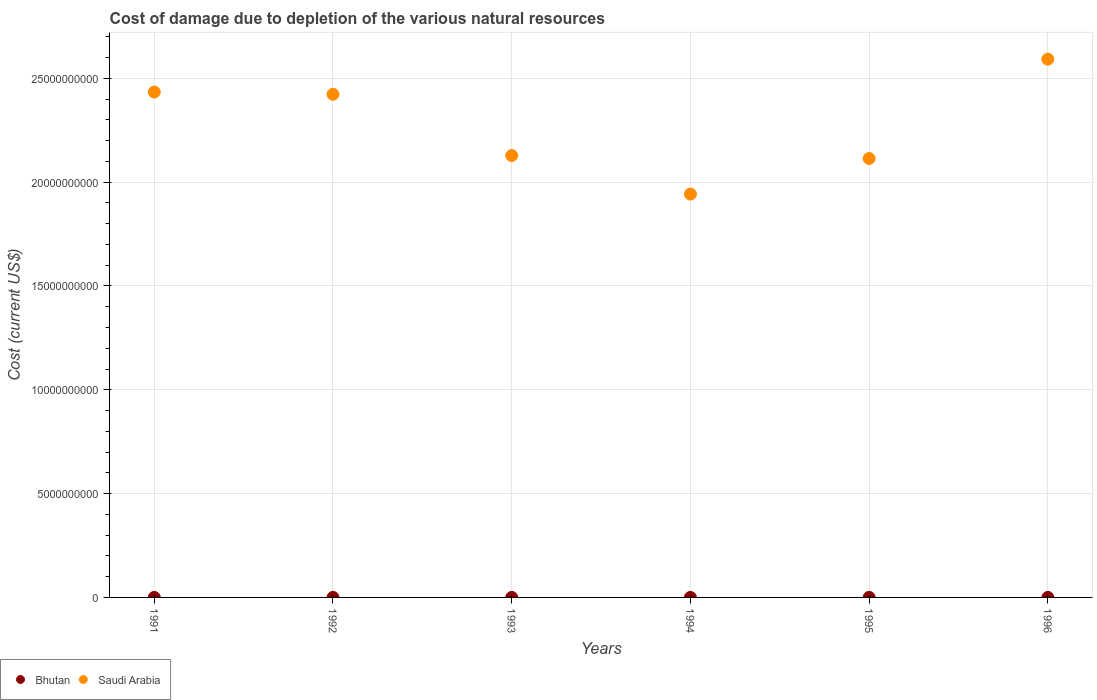How many different coloured dotlines are there?
Offer a very short reply. 2. Is the number of dotlines equal to the number of legend labels?
Keep it short and to the point. Yes. What is the cost of damage caused due to the depletion of various natural resources in Saudi Arabia in 1991?
Keep it short and to the point. 2.43e+1. Across all years, what is the maximum cost of damage caused due to the depletion of various natural resources in Bhutan?
Your response must be concise. 3.59e+05. Across all years, what is the minimum cost of damage caused due to the depletion of various natural resources in Bhutan?
Your response must be concise. 1.20e+04. What is the total cost of damage caused due to the depletion of various natural resources in Saudi Arabia in the graph?
Offer a very short reply. 1.36e+11. What is the difference between the cost of damage caused due to the depletion of various natural resources in Saudi Arabia in 1994 and that in 1995?
Provide a succinct answer. -1.71e+09. What is the difference between the cost of damage caused due to the depletion of various natural resources in Bhutan in 1993 and the cost of damage caused due to the depletion of various natural resources in Saudi Arabia in 1995?
Provide a succinct answer. -2.11e+1. What is the average cost of damage caused due to the depletion of various natural resources in Saudi Arabia per year?
Give a very brief answer. 2.27e+1. In the year 1993, what is the difference between the cost of damage caused due to the depletion of various natural resources in Bhutan and cost of damage caused due to the depletion of various natural resources in Saudi Arabia?
Keep it short and to the point. -2.13e+1. What is the ratio of the cost of damage caused due to the depletion of various natural resources in Saudi Arabia in 1991 to that in 1992?
Your answer should be compact. 1. Is the cost of damage caused due to the depletion of various natural resources in Saudi Arabia in 1992 less than that in 1995?
Give a very brief answer. No. Is the difference between the cost of damage caused due to the depletion of various natural resources in Bhutan in 1993 and 1995 greater than the difference between the cost of damage caused due to the depletion of various natural resources in Saudi Arabia in 1993 and 1995?
Give a very brief answer. No. What is the difference between the highest and the second highest cost of damage caused due to the depletion of various natural resources in Saudi Arabia?
Ensure brevity in your answer.  1.58e+09. What is the difference between the highest and the lowest cost of damage caused due to the depletion of various natural resources in Saudi Arabia?
Ensure brevity in your answer.  6.50e+09. In how many years, is the cost of damage caused due to the depletion of various natural resources in Saudi Arabia greater than the average cost of damage caused due to the depletion of various natural resources in Saudi Arabia taken over all years?
Give a very brief answer. 3. Does the cost of damage caused due to the depletion of various natural resources in Bhutan monotonically increase over the years?
Your answer should be compact. No. Is the cost of damage caused due to the depletion of various natural resources in Bhutan strictly less than the cost of damage caused due to the depletion of various natural resources in Saudi Arabia over the years?
Your answer should be very brief. Yes. What is the difference between two consecutive major ticks on the Y-axis?
Your response must be concise. 5.00e+09. Does the graph contain grids?
Keep it short and to the point. Yes. How are the legend labels stacked?
Your answer should be very brief. Horizontal. What is the title of the graph?
Provide a short and direct response. Cost of damage due to depletion of the various natural resources. What is the label or title of the X-axis?
Provide a short and direct response. Years. What is the label or title of the Y-axis?
Your answer should be compact. Cost (current US$). What is the Cost (current US$) in Bhutan in 1991?
Give a very brief answer. 1.20e+04. What is the Cost (current US$) of Saudi Arabia in 1991?
Offer a terse response. 2.43e+1. What is the Cost (current US$) of Bhutan in 1992?
Offer a very short reply. 2.60e+05. What is the Cost (current US$) in Saudi Arabia in 1992?
Ensure brevity in your answer.  2.42e+1. What is the Cost (current US$) in Bhutan in 1993?
Provide a succinct answer. 7.22e+04. What is the Cost (current US$) in Saudi Arabia in 1993?
Your answer should be compact. 2.13e+1. What is the Cost (current US$) in Bhutan in 1994?
Give a very brief answer. 1.77e+05. What is the Cost (current US$) in Saudi Arabia in 1994?
Your answer should be compact. 1.94e+1. What is the Cost (current US$) in Bhutan in 1995?
Offer a terse response. 3.59e+05. What is the Cost (current US$) of Saudi Arabia in 1995?
Provide a succinct answer. 2.11e+1. What is the Cost (current US$) of Bhutan in 1996?
Your answer should be compact. 3.02e+05. What is the Cost (current US$) in Saudi Arabia in 1996?
Your response must be concise. 2.59e+1. Across all years, what is the maximum Cost (current US$) of Bhutan?
Provide a short and direct response. 3.59e+05. Across all years, what is the maximum Cost (current US$) of Saudi Arabia?
Your answer should be very brief. 2.59e+1. Across all years, what is the minimum Cost (current US$) in Bhutan?
Your answer should be compact. 1.20e+04. Across all years, what is the minimum Cost (current US$) of Saudi Arabia?
Your answer should be very brief. 1.94e+1. What is the total Cost (current US$) of Bhutan in the graph?
Keep it short and to the point. 1.18e+06. What is the total Cost (current US$) in Saudi Arabia in the graph?
Ensure brevity in your answer.  1.36e+11. What is the difference between the Cost (current US$) of Bhutan in 1991 and that in 1992?
Offer a very short reply. -2.48e+05. What is the difference between the Cost (current US$) in Saudi Arabia in 1991 and that in 1992?
Make the answer very short. 1.07e+08. What is the difference between the Cost (current US$) in Bhutan in 1991 and that in 1993?
Give a very brief answer. -6.02e+04. What is the difference between the Cost (current US$) in Saudi Arabia in 1991 and that in 1993?
Make the answer very short. 3.06e+09. What is the difference between the Cost (current US$) in Bhutan in 1991 and that in 1994?
Offer a very short reply. -1.65e+05. What is the difference between the Cost (current US$) of Saudi Arabia in 1991 and that in 1994?
Ensure brevity in your answer.  4.92e+09. What is the difference between the Cost (current US$) in Bhutan in 1991 and that in 1995?
Make the answer very short. -3.47e+05. What is the difference between the Cost (current US$) in Saudi Arabia in 1991 and that in 1995?
Your response must be concise. 3.20e+09. What is the difference between the Cost (current US$) of Bhutan in 1991 and that in 1996?
Give a very brief answer. -2.90e+05. What is the difference between the Cost (current US$) in Saudi Arabia in 1991 and that in 1996?
Make the answer very short. -1.58e+09. What is the difference between the Cost (current US$) of Bhutan in 1992 and that in 1993?
Offer a very short reply. 1.88e+05. What is the difference between the Cost (current US$) in Saudi Arabia in 1992 and that in 1993?
Ensure brevity in your answer.  2.95e+09. What is the difference between the Cost (current US$) of Bhutan in 1992 and that in 1994?
Provide a short and direct response. 8.35e+04. What is the difference between the Cost (current US$) in Saudi Arabia in 1992 and that in 1994?
Provide a succinct answer. 4.81e+09. What is the difference between the Cost (current US$) in Bhutan in 1992 and that in 1995?
Give a very brief answer. -9.91e+04. What is the difference between the Cost (current US$) in Saudi Arabia in 1992 and that in 1995?
Offer a very short reply. 3.09e+09. What is the difference between the Cost (current US$) in Bhutan in 1992 and that in 1996?
Your answer should be compact. -4.18e+04. What is the difference between the Cost (current US$) in Saudi Arabia in 1992 and that in 1996?
Provide a short and direct response. -1.69e+09. What is the difference between the Cost (current US$) of Bhutan in 1993 and that in 1994?
Offer a terse response. -1.05e+05. What is the difference between the Cost (current US$) in Saudi Arabia in 1993 and that in 1994?
Give a very brief answer. 1.86e+09. What is the difference between the Cost (current US$) in Bhutan in 1993 and that in 1995?
Offer a very short reply. -2.87e+05. What is the difference between the Cost (current US$) in Saudi Arabia in 1993 and that in 1995?
Your answer should be compact. 1.42e+08. What is the difference between the Cost (current US$) in Bhutan in 1993 and that in 1996?
Your answer should be compact. -2.30e+05. What is the difference between the Cost (current US$) in Saudi Arabia in 1993 and that in 1996?
Ensure brevity in your answer.  -4.64e+09. What is the difference between the Cost (current US$) in Bhutan in 1994 and that in 1995?
Offer a terse response. -1.83e+05. What is the difference between the Cost (current US$) of Saudi Arabia in 1994 and that in 1995?
Keep it short and to the point. -1.71e+09. What is the difference between the Cost (current US$) of Bhutan in 1994 and that in 1996?
Provide a short and direct response. -1.25e+05. What is the difference between the Cost (current US$) of Saudi Arabia in 1994 and that in 1996?
Your answer should be very brief. -6.50e+09. What is the difference between the Cost (current US$) in Bhutan in 1995 and that in 1996?
Make the answer very short. 5.72e+04. What is the difference between the Cost (current US$) in Saudi Arabia in 1995 and that in 1996?
Your response must be concise. -4.78e+09. What is the difference between the Cost (current US$) of Bhutan in 1991 and the Cost (current US$) of Saudi Arabia in 1992?
Your response must be concise. -2.42e+1. What is the difference between the Cost (current US$) in Bhutan in 1991 and the Cost (current US$) in Saudi Arabia in 1993?
Provide a short and direct response. -2.13e+1. What is the difference between the Cost (current US$) in Bhutan in 1991 and the Cost (current US$) in Saudi Arabia in 1994?
Keep it short and to the point. -1.94e+1. What is the difference between the Cost (current US$) in Bhutan in 1991 and the Cost (current US$) in Saudi Arabia in 1995?
Give a very brief answer. -2.11e+1. What is the difference between the Cost (current US$) in Bhutan in 1991 and the Cost (current US$) in Saudi Arabia in 1996?
Give a very brief answer. -2.59e+1. What is the difference between the Cost (current US$) of Bhutan in 1992 and the Cost (current US$) of Saudi Arabia in 1993?
Provide a succinct answer. -2.13e+1. What is the difference between the Cost (current US$) of Bhutan in 1992 and the Cost (current US$) of Saudi Arabia in 1994?
Ensure brevity in your answer.  -1.94e+1. What is the difference between the Cost (current US$) of Bhutan in 1992 and the Cost (current US$) of Saudi Arabia in 1995?
Offer a terse response. -2.11e+1. What is the difference between the Cost (current US$) of Bhutan in 1992 and the Cost (current US$) of Saudi Arabia in 1996?
Provide a short and direct response. -2.59e+1. What is the difference between the Cost (current US$) in Bhutan in 1993 and the Cost (current US$) in Saudi Arabia in 1994?
Make the answer very short. -1.94e+1. What is the difference between the Cost (current US$) of Bhutan in 1993 and the Cost (current US$) of Saudi Arabia in 1995?
Provide a short and direct response. -2.11e+1. What is the difference between the Cost (current US$) of Bhutan in 1993 and the Cost (current US$) of Saudi Arabia in 1996?
Offer a very short reply. -2.59e+1. What is the difference between the Cost (current US$) in Bhutan in 1994 and the Cost (current US$) in Saudi Arabia in 1995?
Offer a terse response. -2.11e+1. What is the difference between the Cost (current US$) in Bhutan in 1994 and the Cost (current US$) in Saudi Arabia in 1996?
Offer a terse response. -2.59e+1. What is the difference between the Cost (current US$) of Bhutan in 1995 and the Cost (current US$) of Saudi Arabia in 1996?
Provide a succinct answer. -2.59e+1. What is the average Cost (current US$) in Bhutan per year?
Give a very brief answer. 1.97e+05. What is the average Cost (current US$) in Saudi Arabia per year?
Offer a very short reply. 2.27e+1. In the year 1991, what is the difference between the Cost (current US$) of Bhutan and Cost (current US$) of Saudi Arabia?
Your answer should be compact. -2.43e+1. In the year 1992, what is the difference between the Cost (current US$) in Bhutan and Cost (current US$) in Saudi Arabia?
Offer a very short reply. -2.42e+1. In the year 1993, what is the difference between the Cost (current US$) in Bhutan and Cost (current US$) in Saudi Arabia?
Give a very brief answer. -2.13e+1. In the year 1994, what is the difference between the Cost (current US$) of Bhutan and Cost (current US$) of Saudi Arabia?
Give a very brief answer. -1.94e+1. In the year 1995, what is the difference between the Cost (current US$) of Bhutan and Cost (current US$) of Saudi Arabia?
Provide a succinct answer. -2.11e+1. In the year 1996, what is the difference between the Cost (current US$) of Bhutan and Cost (current US$) of Saudi Arabia?
Your response must be concise. -2.59e+1. What is the ratio of the Cost (current US$) in Bhutan in 1991 to that in 1992?
Your answer should be compact. 0.05. What is the ratio of the Cost (current US$) of Bhutan in 1991 to that in 1993?
Your answer should be compact. 0.17. What is the ratio of the Cost (current US$) of Saudi Arabia in 1991 to that in 1993?
Offer a terse response. 1.14. What is the ratio of the Cost (current US$) of Bhutan in 1991 to that in 1994?
Provide a succinct answer. 0.07. What is the ratio of the Cost (current US$) in Saudi Arabia in 1991 to that in 1994?
Your answer should be very brief. 1.25. What is the ratio of the Cost (current US$) of Bhutan in 1991 to that in 1995?
Your answer should be very brief. 0.03. What is the ratio of the Cost (current US$) of Saudi Arabia in 1991 to that in 1995?
Offer a terse response. 1.15. What is the ratio of the Cost (current US$) in Bhutan in 1991 to that in 1996?
Your answer should be compact. 0.04. What is the ratio of the Cost (current US$) in Saudi Arabia in 1991 to that in 1996?
Provide a succinct answer. 0.94. What is the ratio of the Cost (current US$) in Bhutan in 1992 to that in 1993?
Provide a short and direct response. 3.6. What is the ratio of the Cost (current US$) of Saudi Arabia in 1992 to that in 1993?
Provide a short and direct response. 1.14. What is the ratio of the Cost (current US$) of Bhutan in 1992 to that in 1994?
Give a very brief answer. 1.47. What is the ratio of the Cost (current US$) in Saudi Arabia in 1992 to that in 1994?
Give a very brief answer. 1.25. What is the ratio of the Cost (current US$) of Bhutan in 1992 to that in 1995?
Give a very brief answer. 0.72. What is the ratio of the Cost (current US$) of Saudi Arabia in 1992 to that in 1995?
Offer a very short reply. 1.15. What is the ratio of the Cost (current US$) of Bhutan in 1992 to that in 1996?
Your answer should be very brief. 0.86. What is the ratio of the Cost (current US$) of Saudi Arabia in 1992 to that in 1996?
Give a very brief answer. 0.93. What is the ratio of the Cost (current US$) of Bhutan in 1993 to that in 1994?
Ensure brevity in your answer.  0.41. What is the ratio of the Cost (current US$) in Saudi Arabia in 1993 to that in 1994?
Give a very brief answer. 1.1. What is the ratio of the Cost (current US$) of Bhutan in 1993 to that in 1995?
Provide a succinct answer. 0.2. What is the ratio of the Cost (current US$) in Bhutan in 1993 to that in 1996?
Provide a short and direct response. 0.24. What is the ratio of the Cost (current US$) in Saudi Arabia in 1993 to that in 1996?
Your answer should be very brief. 0.82. What is the ratio of the Cost (current US$) in Bhutan in 1994 to that in 1995?
Your response must be concise. 0.49. What is the ratio of the Cost (current US$) of Saudi Arabia in 1994 to that in 1995?
Ensure brevity in your answer.  0.92. What is the ratio of the Cost (current US$) of Bhutan in 1994 to that in 1996?
Give a very brief answer. 0.59. What is the ratio of the Cost (current US$) of Saudi Arabia in 1994 to that in 1996?
Your answer should be compact. 0.75. What is the ratio of the Cost (current US$) of Bhutan in 1995 to that in 1996?
Give a very brief answer. 1.19. What is the ratio of the Cost (current US$) in Saudi Arabia in 1995 to that in 1996?
Your answer should be very brief. 0.82. What is the difference between the highest and the second highest Cost (current US$) of Bhutan?
Offer a very short reply. 5.72e+04. What is the difference between the highest and the second highest Cost (current US$) in Saudi Arabia?
Provide a succinct answer. 1.58e+09. What is the difference between the highest and the lowest Cost (current US$) of Bhutan?
Offer a terse response. 3.47e+05. What is the difference between the highest and the lowest Cost (current US$) in Saudi Arabia?
Ensure brevity in your answer.  6.50e+09. 